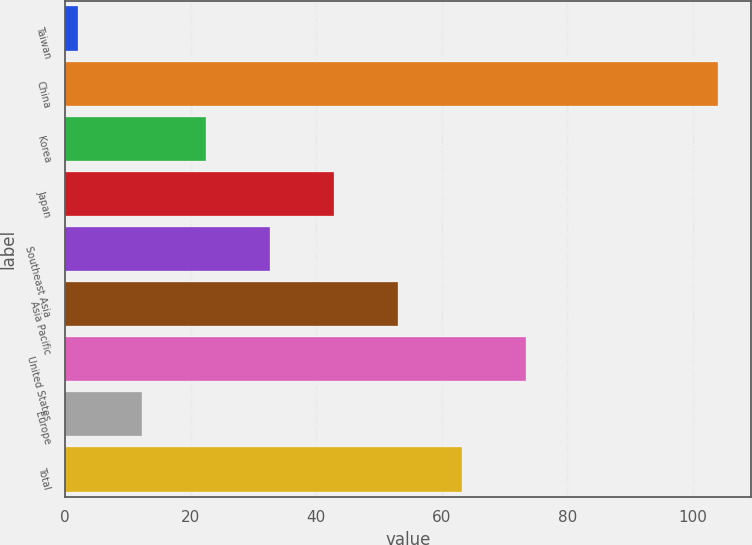Convert chart to OTSL. <chart><loc_0><loc_0><loc_500><loc_500><bar_chart><fcel>Taiwan<fcel>China<fcel>Korea<fcel>Japan<fcel>Southeast Asia<fcel>Asia Pacific<fcel>United States<fcel>Europe<fcel>Total<nl><fcel>2<fcel>104<fcel>22.4<fcel>42.8<fcel>32.6<fcel>53<fcel>73.4<fcel>12.2<fcel>63.2<nl></chart> 